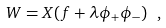<formula> <loc_0><loc_0><loc_500><loc_500>W = X ( f + \lambda \phi _ { + } \phi _ { - } ) \ ,</formula> 